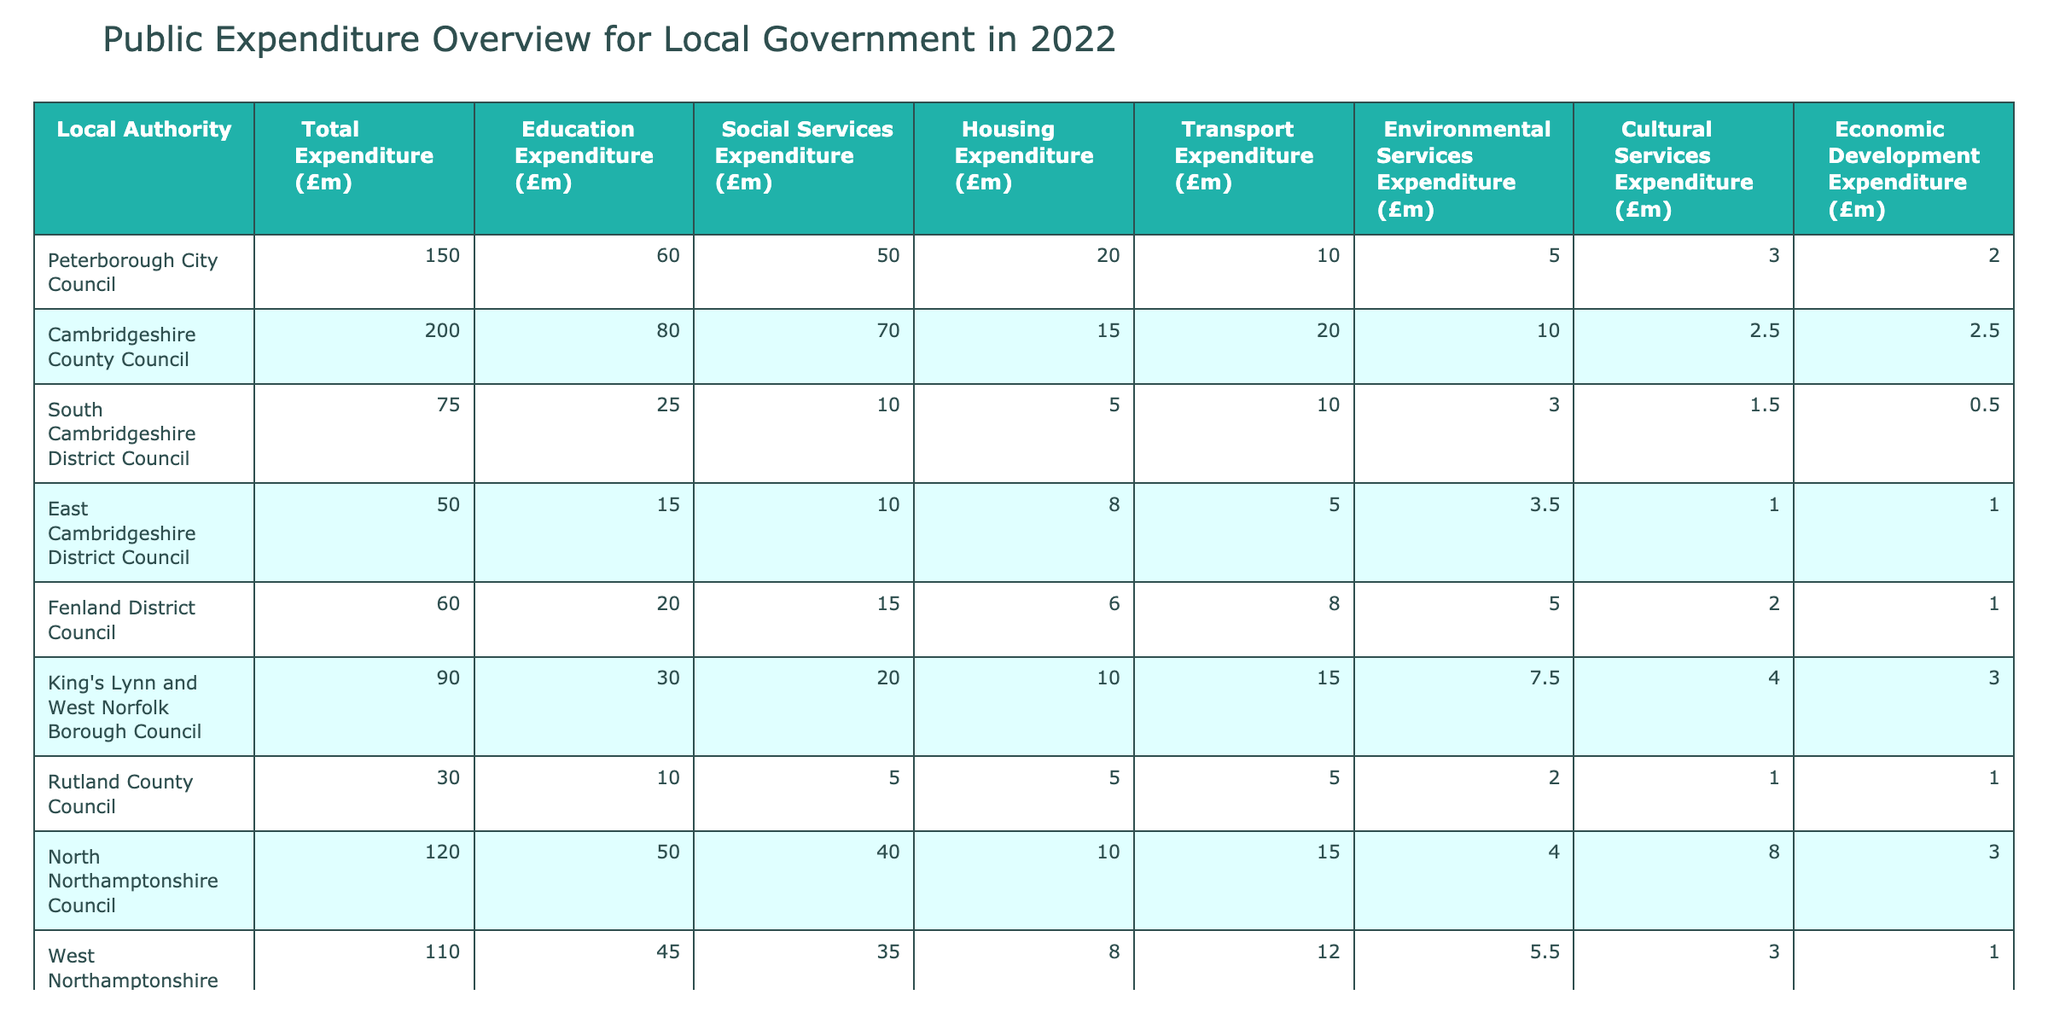What is the total expenditure for Peterborough City Council? The table indicates that the total expenditure for Peterborough City Council is specifically listed as £150.0 million.
Answer: £150.0 million Which local authority has the highest education expenditure? By comparing the education expenditure for each authority, Cambridgeshire County Council has the highest education expenditure listed at £80.0 million.
Answer: Cambridgeshire County Council What is the total social services expenditure for all local authorities combined? Adding all the social services expenditures: £50.0 + £70.0 + £10.0 + £10.0 + £15.0 + £20.0 + £5.0 + £40.0 + £35.0 = £315.0 million.
Answer: £315.0 million Did Rutland County Council exceed £30 million in total expenditure? Rutland County Council's total expenditure is listed as £30.0 million, which means it did not exceed that amount.
Answer: No What is the average housing expenditure for the local authorities listed? The housing expenditures are £20.0, £15.0, £5.0, £8.0, £6.0, £10.0, £5.0, £10.0, and £8.0 million. Adding these gives £69.0 million. Dividing by 9 (the number of authorities) gives an average of £7.67 million (rounded to two decimal places).
Answer: £7.67 million Which authority has the lowest total expenditure? By checking the total expenditures, Rutland County Council has the lowest amount listed at £30.0 million.
Answer: Rutland County Council How much does North Northamptonshire Council spend on environmental services? The table shows that North Northamptonshire Council has an environmental services expenditure of £4.0 million.
Answer: £4.0 million What is the difference in total expenditure between Cambridgeshire County Council and South Cambridgeshire District Council? Cambridgeshire County Council's total expenditure is £200.0 million and South Cambridgeshire District Council's total is £75.0 million. The difference is £200.0 - £75.0 = £125.0 million.
Answer: £125.0 million Which council has the highest expenditure on cultural services? Comparing cultural services expenditures, King's Lynn and West Norfolk Borough Council has the highest amount at £4.0 million.
Answer: King's Lynn and West Norfolk Borough Council If we group authorities by total expenditure being above or below £100 million, how many fall into each category? The councils above £100 million are Cambridgeshire County Council (£200.0) and North Northamptonshire Council (£120.0) and West Northamptonshire Council (£110.0), totaling 3. The others are below £100 million.
Answer: 3 above, 6 below 